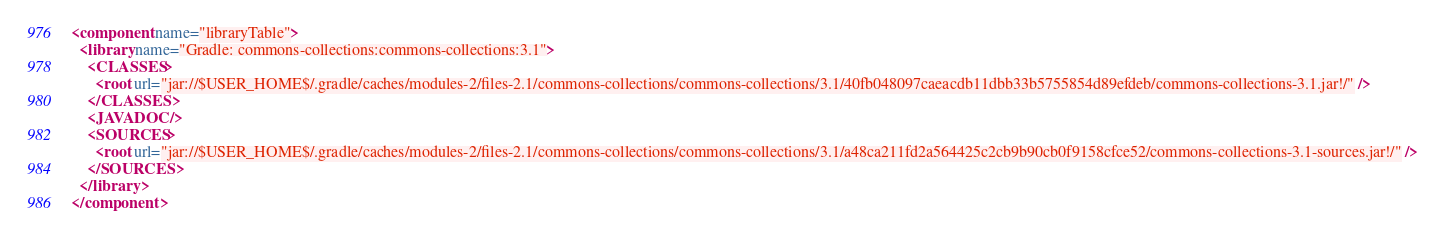<code> <loc_0><loc_0><loc_500><loc_500><_XML_><component name="libraryTable">
  <library name="Gradle: commons-collections:commons-collections:3.1">
    <CLASSES>
      <root url="jar://$USER_HOME$/.gradle/caches/modules-2/files-2.1/commons-collections/commons-collections/3.1/40fb048097caeacdb11dbb33b5755854d89efdeb/commons-collections-3.1.jar!/" />
    </CLASSES>
    <JAVADOC />
    <SOURCES>
      <root url="jar://$USER_HOME$/.gradle/caches/modules-2/files-2.1/commons-collections/commons-collections/3.1/a48ca211fd2a564425c2cb9b90cb0f9158cfce52/commons-collections-3.1-sources.jar!/" />
    </SOURCES>
  </library>
</component></code> 